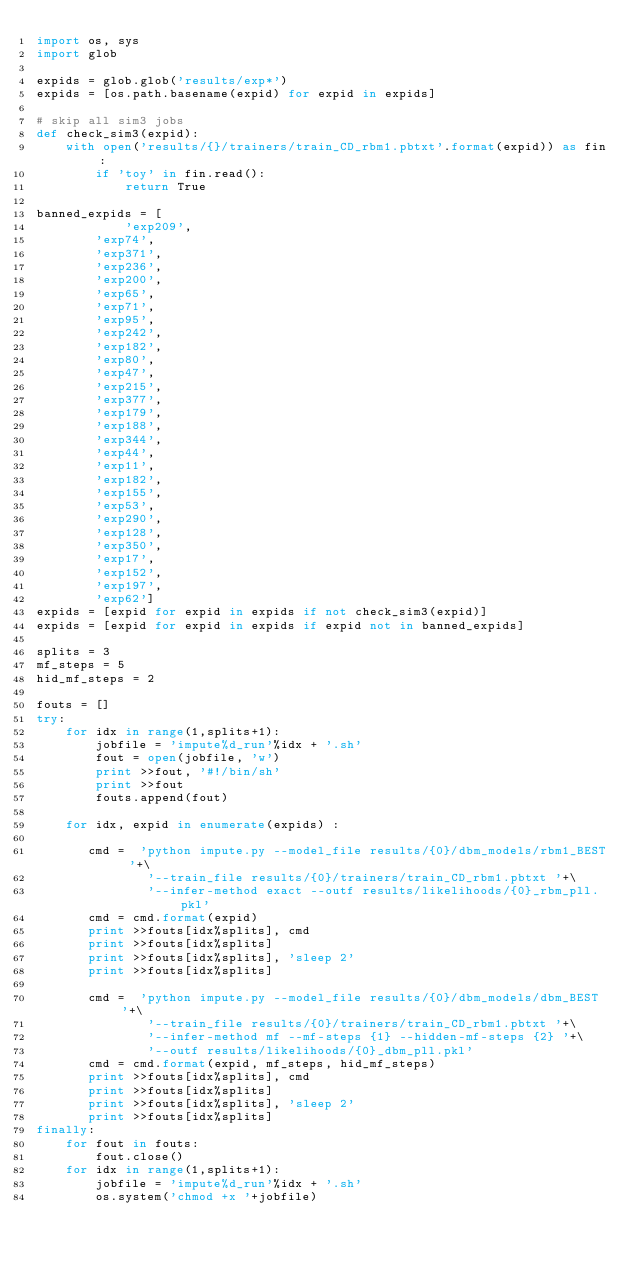<code> <loc_0><loc_0><loc_500><loc_500><_Python_>import os, sys
import glob

expids = glob.glob('results/exp*')
expids = [os.path.basename(expid) for expid in expids]

# skip all sim3 jobs
def check_sim3(expid):
    with open('results/{}/trainers/train_CD_rbm1.pbtxt'.format(expid)) as fin:
        if 'toy' in fin.read():
            return True

banned_expids = [
            'exp209',
        'exp74',
        'exp371',
        'exp236',
        'exp200',
        'exp65',
        'exp71',
        'exp95',
        'exp242',
        'exp182',
        'exp80',
        'exp47',
        'exp215',
        'exp377',
        'exp179',
        'exp188',
        'exp344',
        'exp44',
        'exp11',
        'exp182',
        'exp155',
        'exp53',
        'exp290',
        'exp128',
        'exp350',
        'exp17',
        'exp152',
        'exp197',
        'exp62']
expids = [expid for expid in expids if not check_sim3(expid)]
expids = [expid for expid in expids if expid not in banned_expids]

splits = 3 
mf_steps = 5
hid_mf_steps = 2

fouts = []
try:
    for idx in range(1,splits+1):
        jobfile = 'impute%d_run'%idx + '.sh'
        fout = open(jobfile, 'w')
        print >>fout, '#!/bin/sh'
        print >>fout
        fouts.append(fout)

    for idx, expid in enumerate(expids) : 

       cmd =  'python impute.py --model_file results/{0}/dbm_models/rbm1_BEST '+\
               '--train_file results/{0}/trainers/train_CD_rbm1.pbtxt '+\
               '--infer-method exact --outf results/likelihoods/{0}_rbm_pll.pkl'
       cmd = cmd.format(expid)
       print >>fouts[idx%splits], cmd
       print >>fouts[idx%splits]
       print >>fouts[idx%splits], 'sleep 2'
       print >>fouts[idx%splits]

       cmd =  'python impute.py --model_file results/{0}/dbm_models/dbm_BEST '+\
               '--train_file results/{0}/trainers/train_CD_rbm1.pbtxt '+\
               '--infer-method mf --mf-steps {1} --hidden-mf-steps {2} '+\
               '--outf results/likelihoods/{0}_dbm_pll.pkl'
       cmd = cmd.format(expid, mf_steps, hid_mf_steps)
       print >>fouts[idx%splits], cmd
       print >>fouts[idx%splits]
       print >>fouts[idx%splits], 'sleep 2'
       print >>fouts[idx%splits]
finally:
    for fout in fouts: 
        fout.close()
    for idx in range(1,splits+1):
        jobfile = 'impute%d_run'%idx + '.sh'
        os.system('chmod +x '+jobfile)
</code> 